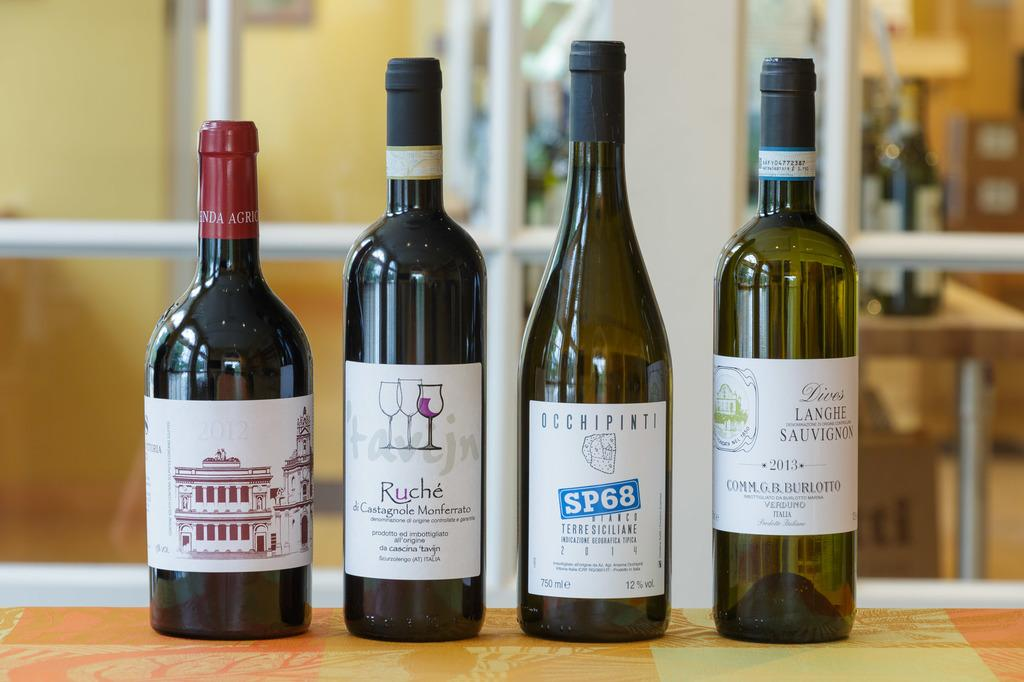<image>
Create a compact narrative representing the image presented. A bottle labeled Ruche is surrounded by other bottles. 